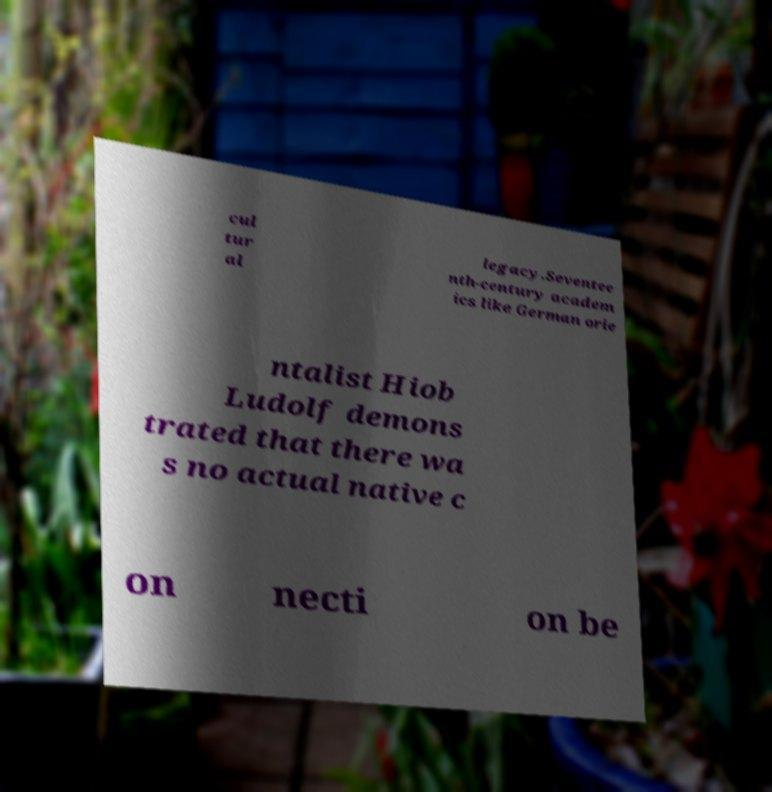For documentation purposes, I need the text within this image transcribed. Could you provide that? cul tur al legacy.Seventee nth-century academ ics like German orie ntalist Hiob Ludolf demons trated that there wa s no actual native c on necti on be 